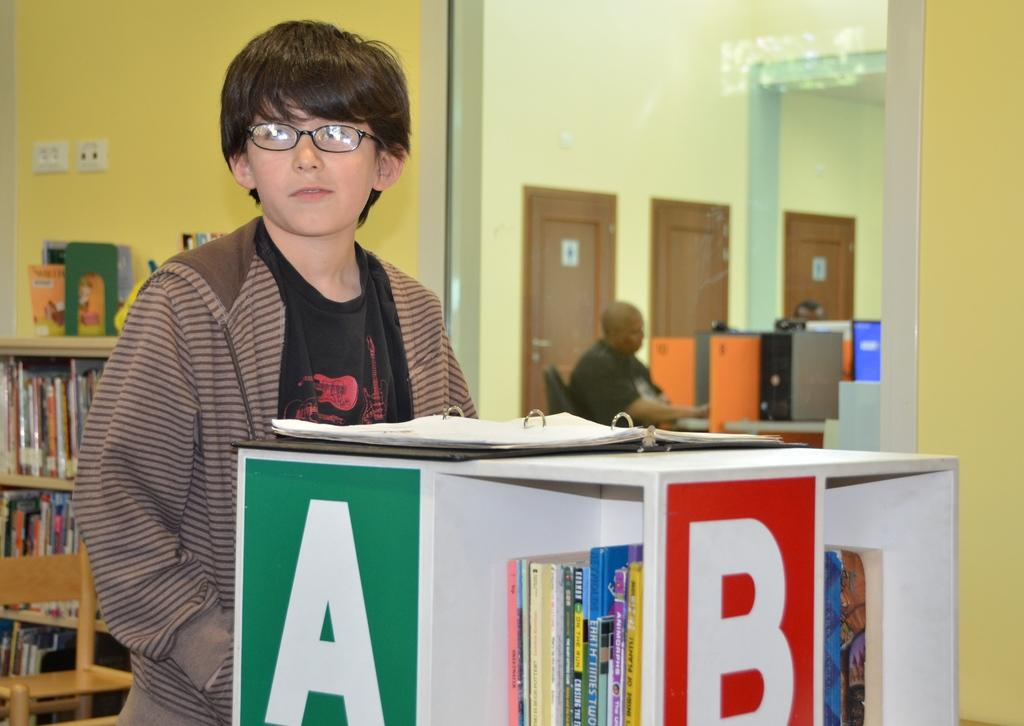<image>
Share a concise interpretation of the image provided. A boy with eye glasses standing in front of shelves that says A and B 